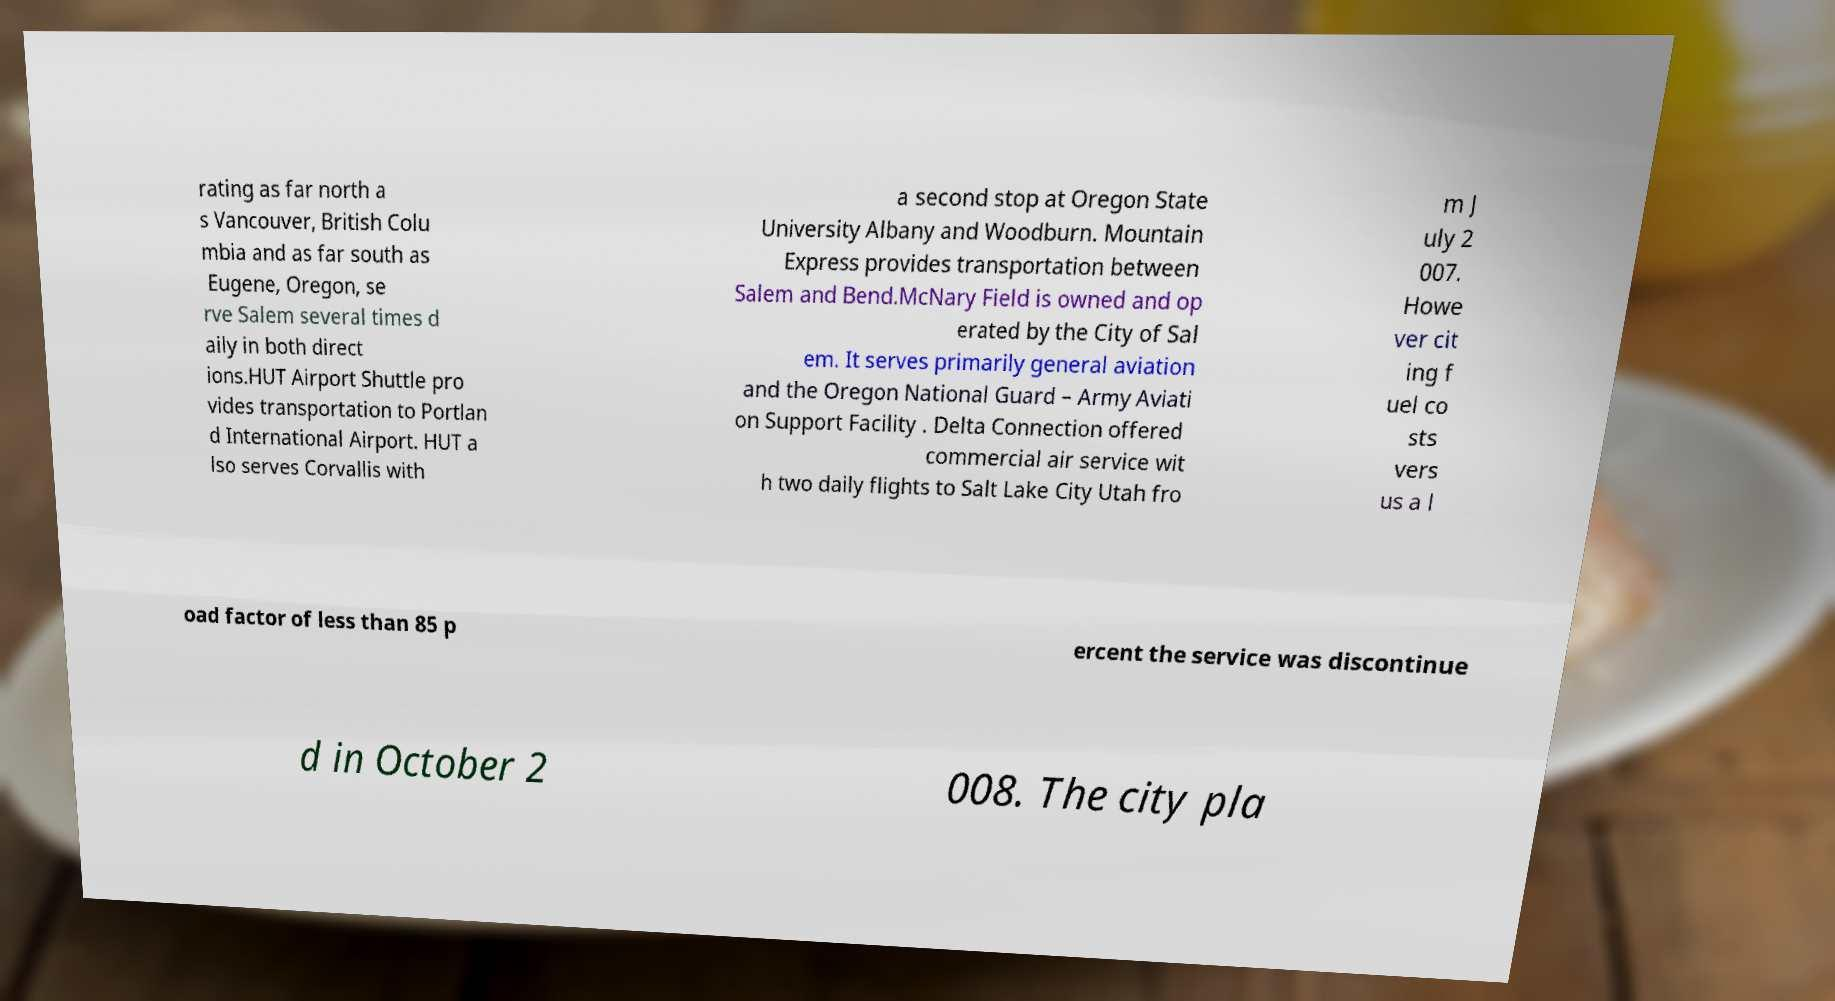Can you accurately transcribe the text from the provided image for me? rating as far north a s Vancouver, British Colu mbia and as far south as Eugene, Oregon, se rve Salem several times d aily in both direct ions.HUT Airport Shuttle pro vides transportation to Portlan d International Airport. HUT a lso serves Corvallis with a second stop at Oregon State University Albany and Woodburn. Mountain Express provides transportation between Salem and Bend.McNary Field is owned and op erated by the City of Sal em. It serves primarily general aviation and the Oregon National Guard – Army Aviati on Support Facility . Delta Connection offered commercial air service wit h two daily flights to Salt Lake City Utah fro m J uly 2 007. Howe ver cit ing f uel co sts vers us a l oad factor of less than 85 p ercent the service was discontinue d in October 2 008. The city pla 